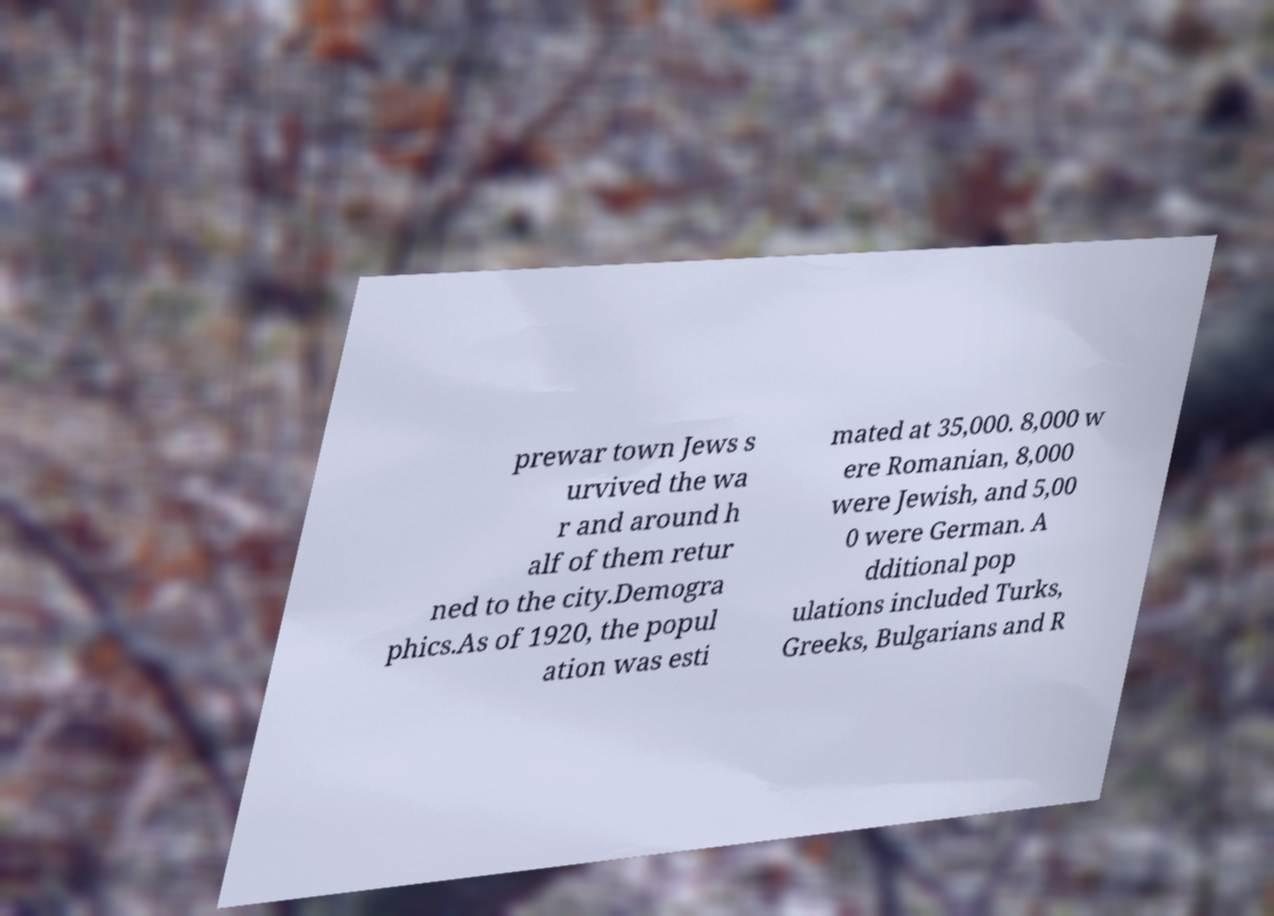What messages or text are displayed in this image? I need them in a readable, typed format. prewar town Jews s urvived the wa r and around h alf of them retur ned to the city.Demogra phics.As of 1920, the popul ation was esti mated at 35,000. 8,000 w ere Romanian, 8,000 were Jewish, and 5,00 0 were German. A dditional pop ulations included Turks, Greeks, Bulgarians and R 